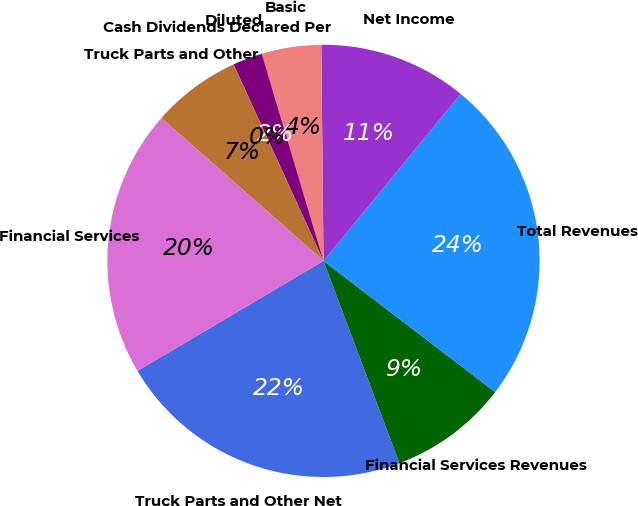Convert chart. <chart><loc_0><loc_0><loc_500><loc_500><pie_chart><fcel>Truck Parts and Other Net<fcel>Financial Services Revenues<fcel>Total Revenues<fcel>Net Income<fcel>Basic<fcel>Diluted<fcel>Cash Dividends Declared Per<fcel>Truck Parts and Other<fcel>Financial Services<nl><fcel>22.22%<fcel>8.89%<fcel>24.44%<fcel>11.11%<fcel>4.45%<fcel>2.22%<fcel>0.0%<fcel>6.67%<fcel>20.0%<nl></chart> 